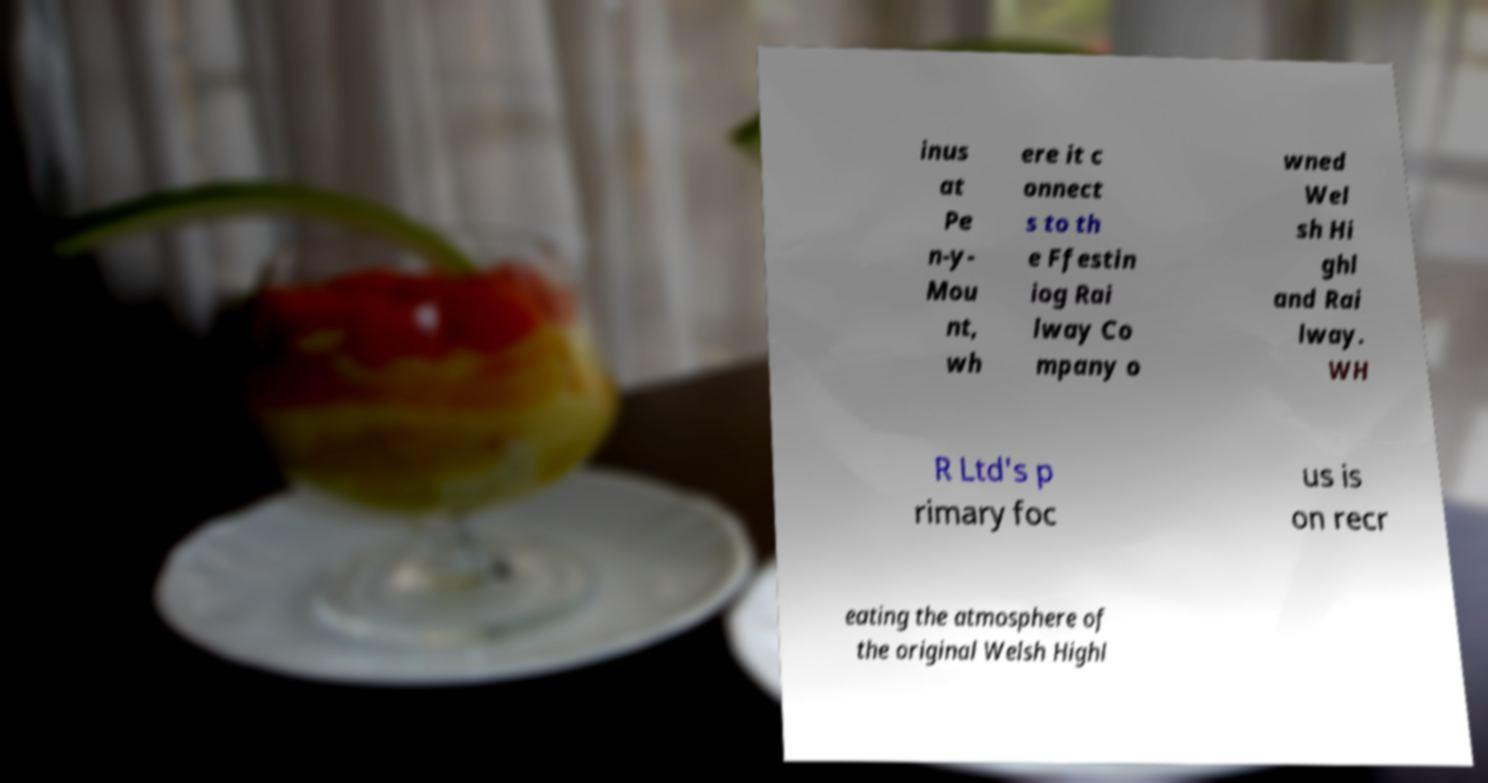Could you assist in decoding the text presented in this image and type it out clearly? inus at Pe n-y- Mou nt, wh ere it c onnect s to th e Ffestin iog Rai lway Co mpany o wned Wel sh Hi ghl and Rai lway. WH R Ltd's p rimary foc us is on recr eating the atmosphere of the original Welsh Highl 